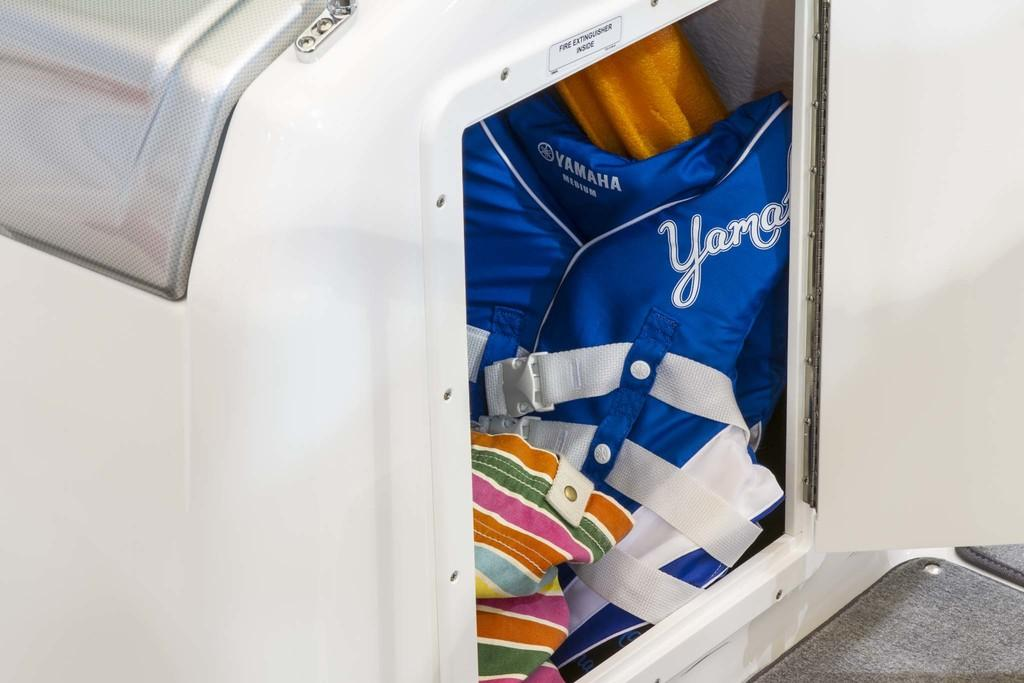What object is white and visible in the image? There is a white box in the image. What type of clothing can be seen in the image? There are dresses in the image. What type of lace is used to decorate the dresses in the image? There is no information about the type of lace used to decorate the dresses in the image. Can you tell me how many orders have been placed for the dresses in the image? There is no information about orders for the dresses in the image. 